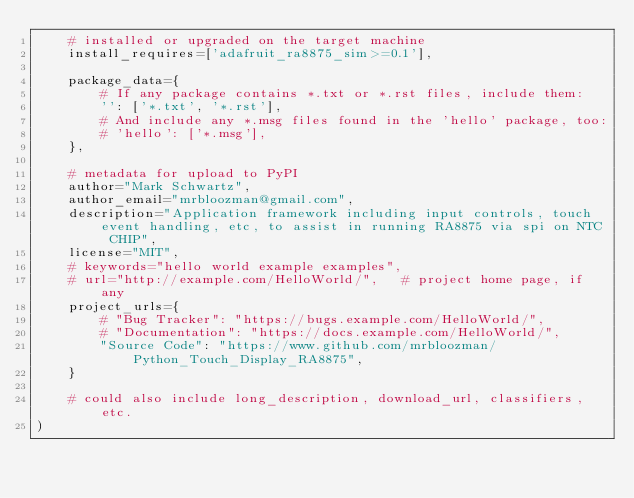<code> <loc_0><loc_0><loc_500><loc_500><_Python_>    # installed or upgraded on the target machine
    install_requires=['adafruit_ra8875_sim>=0.1'],

    package_data={
        # If any package contains *.txt or *.rst files, include them:
        '': ['*.txt', '*.rst'],
        # And include any *.msg files found in the 'hello' package, too:
        # 'hello': ['*.msg'],
    },

    # metadata for upload to PyPI
    author="Mark Schwartz",
    author_email="mrbloozman@gmail.com",
    description="Application framework including input controls, touch event handling, etc, to assist in running RA8875 via spi on NTC CHIP",
    license="MIT",
    # keywords="hello world example examples",
    # url="http://example.com/HelloWorld/",   # project home page, if any
    project_urls={
        # "Bug Tracker": "https://bugs.example.com/HelloWorld/",
        # "Documentation": "https://docs.example.com/HelloWorld/",
        "Source Code": "https://www.github.com/mrbloozman/Python_Touch_Display_RA8875",
    }

    # could also include long_description, download_url, classifiers, etc.
)</code> 